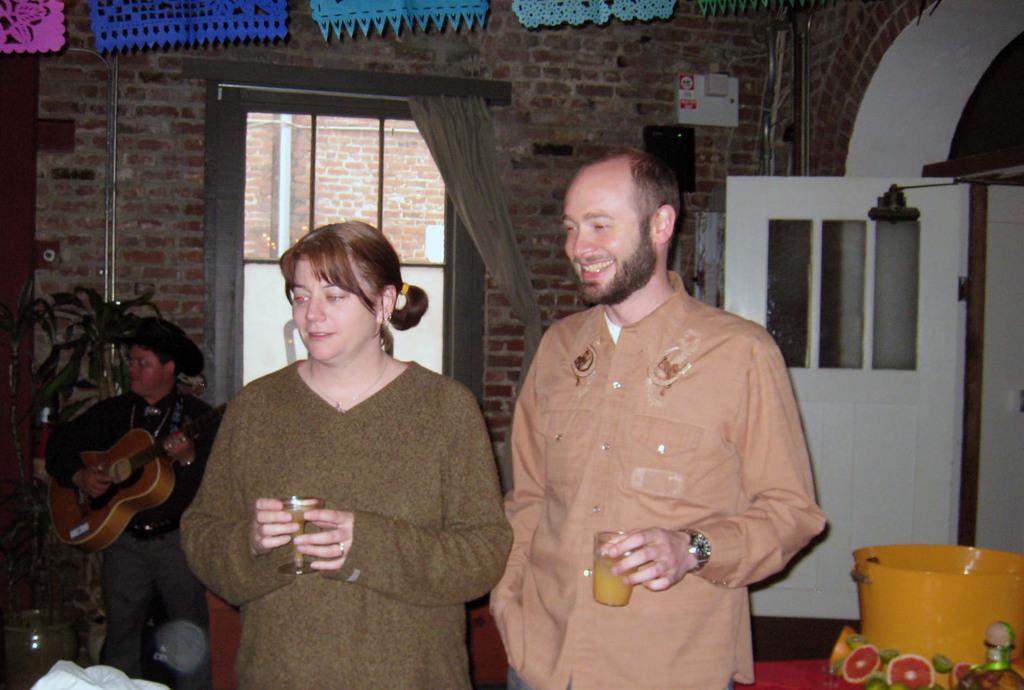How would you summarize this image in a sentence or two? In this image we can see two persons are standing and smiling, and holding a glass in the hand, and at back a person is standing and playing the guitar, and here is the wall made of bricks, and at back here is the door. 